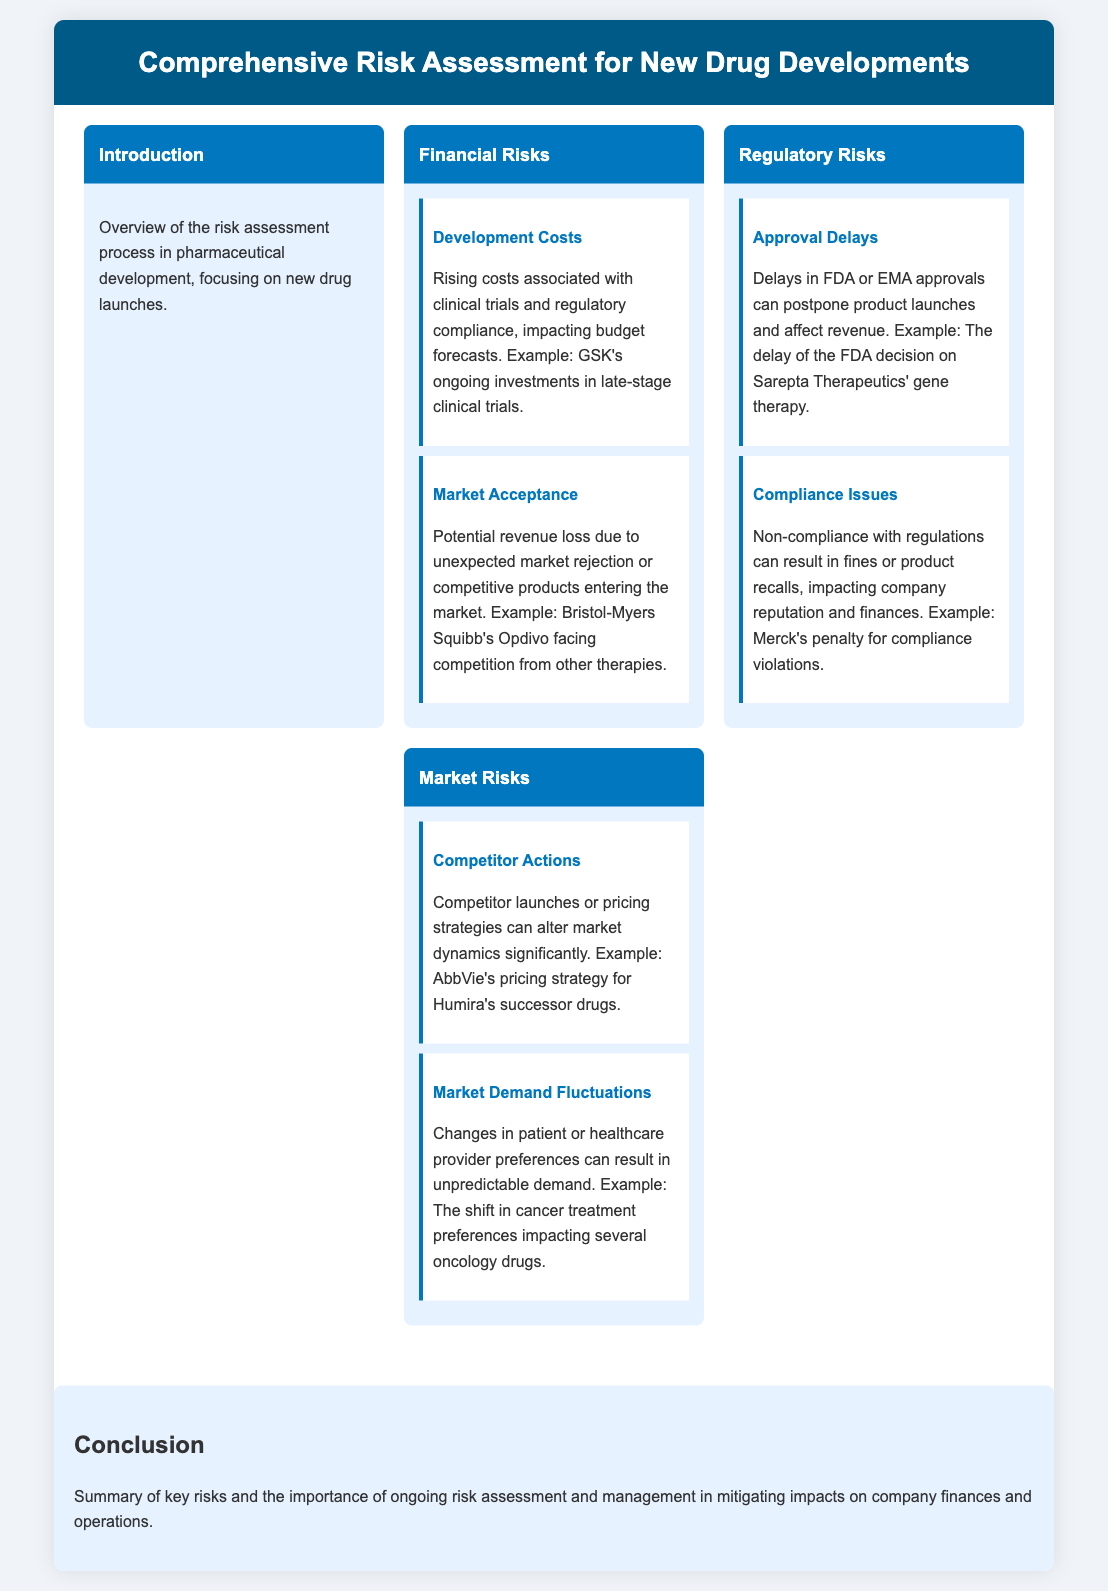What are the main types of risks outlined? The document specifies three main types of risks associated with new drug developments: Financial Risks, Regulatory Risks, and Market Risks.
Answer: Financial Risks, Regulatory Risks, Market Risks What is the example for Development Costs? The example given is GSK's ongoing investments in late-stage clinical trials.
Answer: GSK's ongoing investments in late-stage clinical trials What is a potential consequence of Approval Delays? The document states that delays in FDA or EMA approvals can postpone product launches, affecting revenue.
Answer: Postpone product launches What might lead to Market Demand Fluctuations? Changes in patient or healthcare provider preferences can result in unpredictable demand.
Answer: Changes in preferences Which company faced issues due to compliance violations? The example provided is Merck, which faced penalties for compliance violations.
Answer: Merck What can non-compliance with regulations result in? The document mentions that non-compliance can result in fines or product recalls.
Answer: Fines or product recalls What does the conclusion emphasize? The conclusion emphasizes the importance of ongoing risk assessment and management to mitigate impacts on finances and operations.
Answer: Ongoing risk assessment and management What risk is associated with unexpected market rejection? The document describes market acceptance as a risk related to potential revenue loss from unexpected market rejection.
Answer: Market acceptance 